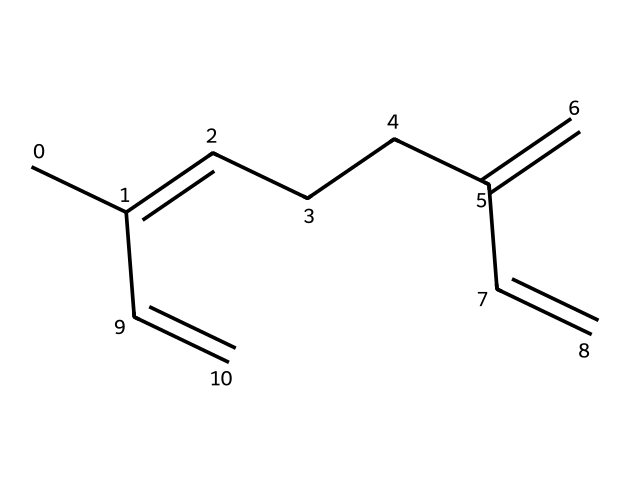How many carbon atoms are in myrcene? The SMILES representation indicates the arrangement of myrcene. By counting the 'C' characters in the structure, we find there are eleven carbon atoms.
Answer: eleven What type of functional group is present in myrcene? The structure of myrcene includes double bonds, indicating that it contains alkenes. The presence of the multiple C=C bonds suggests that myrcene is an unsaturated hydrocarbon.
Answer: alkene How many double bonds does myrcene contain? By examining the structure in the SMILES representation, we can see there are three separate instances of double bonds (C=C), confirming that there are three double bonds present in myrcene.
Answer: three Is myrcene a terpene? Myrcene is classified as a terpene due to its structure and properties. Terpenes are a class of compounds derived from isoprene units, and myrcene fits into this classification.
Answer: yes What is the degree of saturation of myrcene? To determine the degree of saturation, we consider the number of carbon atoms and the number of hydrogen atoms. Myrcene, with its structure, has two fewer hydrogen atoms than it would if fully saturated, thus indicating it has three degrees of unsaturation due to its double bonds.
Answer: three What characteristic aroma or flavor does myrcene provide? Myrcene is known to provide a musky, herbal aroma which contributes to the overall scent profile of mangoes where it is commonly found.
Answer: musky 